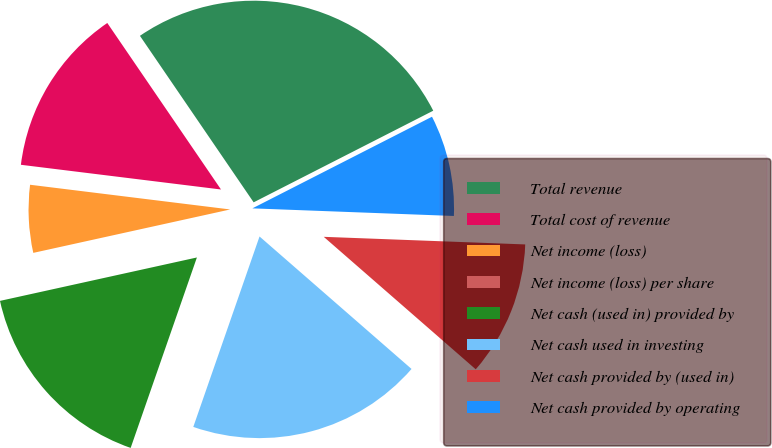Convert chart. <chart><loc_0><loc_0><loc_500><loc_500><pie_chart><fcel>Total revenue<fcel>Total cost of revenue<fcel>Net income (loss)<fcel>Net income (loss) per share<fcel>Net cash (used in) provided by<fcel>Net cash used in investing<fcel>Net cash provided by (used in)<fcel>Net cash provided by operating<nl><fcel>27.03%<fcel>13.51%<fcel>5.41%<fcel>0.0%<fcel>16.22%<fcel>18.92%<fcel>10.81%<fcel>8.11%<nl></chart> 